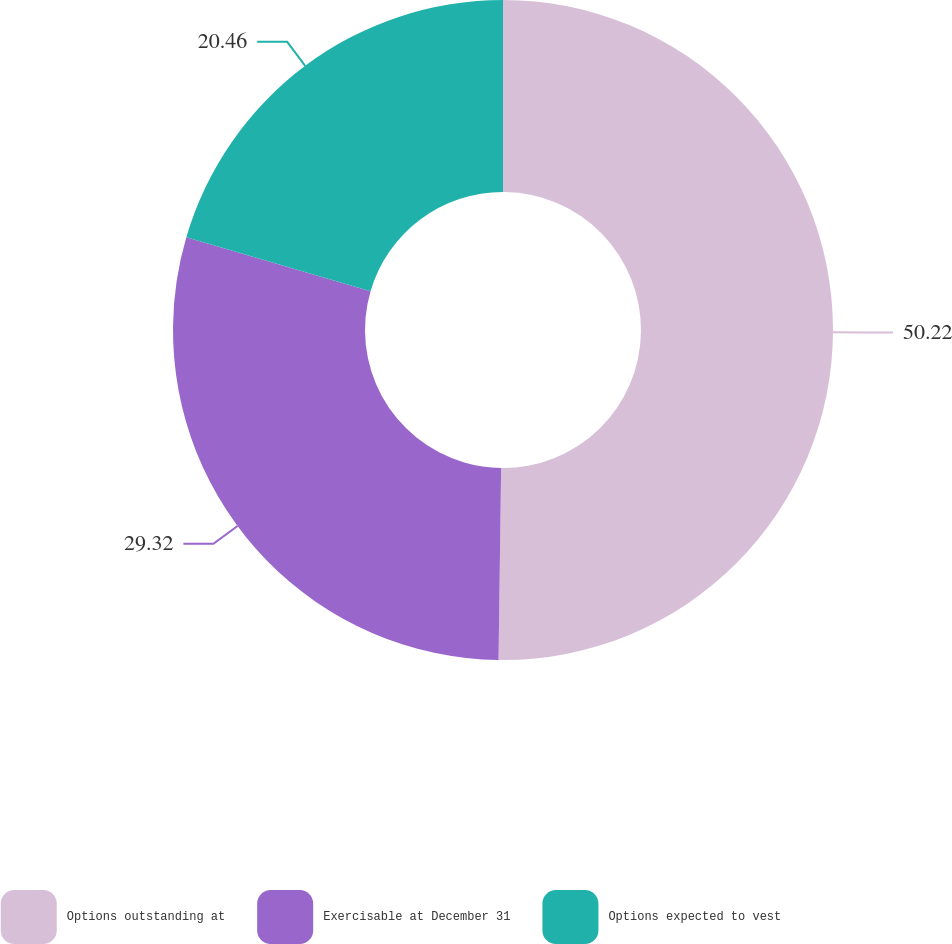Convert chart to OTSL. <chart><loc_0><loc_0><loc_500><loc_500><pie_chart><fcel>Options outstanding at<fcel>Exercisable at December 31<fcel>Options expected to vest<nl><fcel>50.21%<fcel>29.32%<fcel>20.46%<nl></chart> 